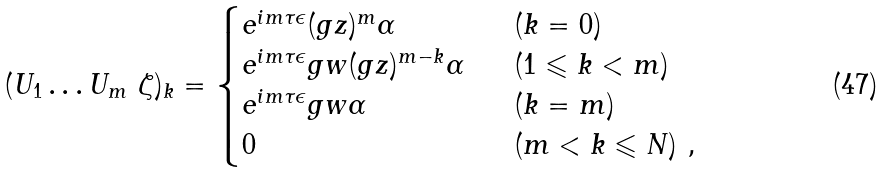Convert formula to latex. <formula><loc_0><loc_0><loc_500><loc_500>( U _ { 1 } \dots U _ { m } \ \zeta ) _ { k } = \begin{cases} e ^ { i m \tau \epsilon } ( g z ) ^ { m } \alpha \ & \ ( k = 0 ) \\ e ^ { i m \tau \epsilon } g w ( g z ) ^ { m - k } \alpha \ & \ ( 1 \leqslant k < m ) \\ e ^ { i m \tau \epsilon } g w \alpha \ & \ ( k = m ) \\ 0 \ & \ ( m < k \leqslant N ) \ , \end{cases}</formula> 